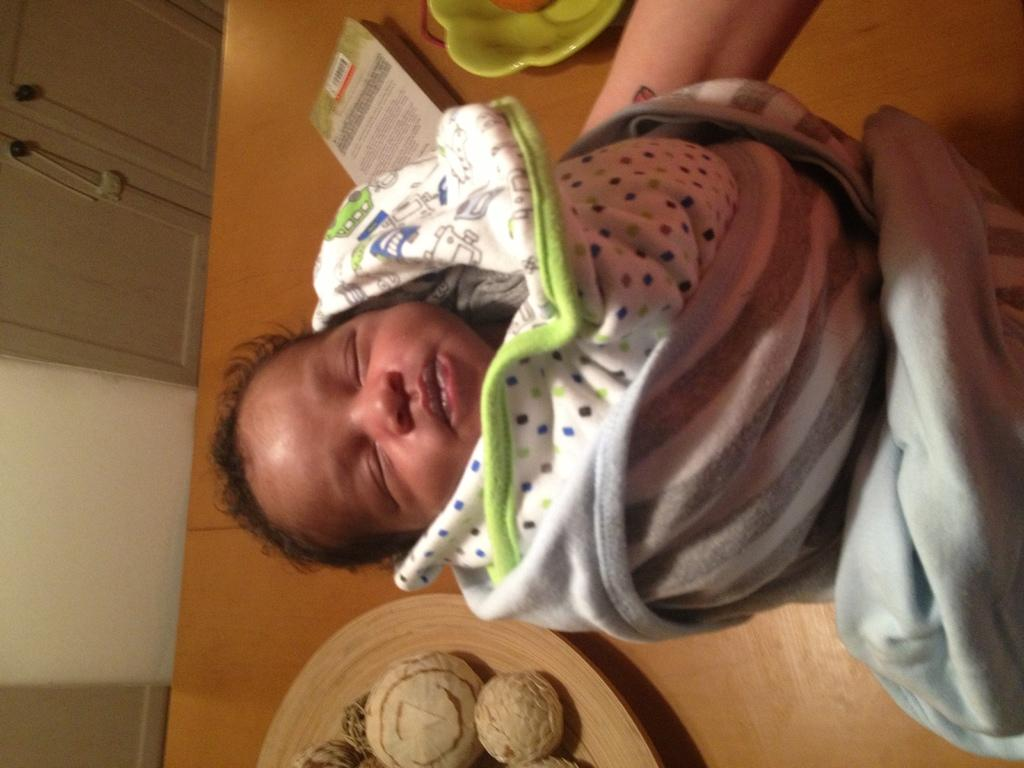What is the main subject of the image? The main subject of the image is a kid. How is the kid positioned in the image? The kid is wrapped in cloth and being held by a person. What objects can be seen on the table in the image? There is a book, a bowl, and items on a plate on the table in the image. What architectural features are present in the image? There is a wall on the left side of the image and doors visible. How many balls are being juggled by the kid in the image? There are no balls present in the image; the kid is wrapped in cloth and being held by a person. 